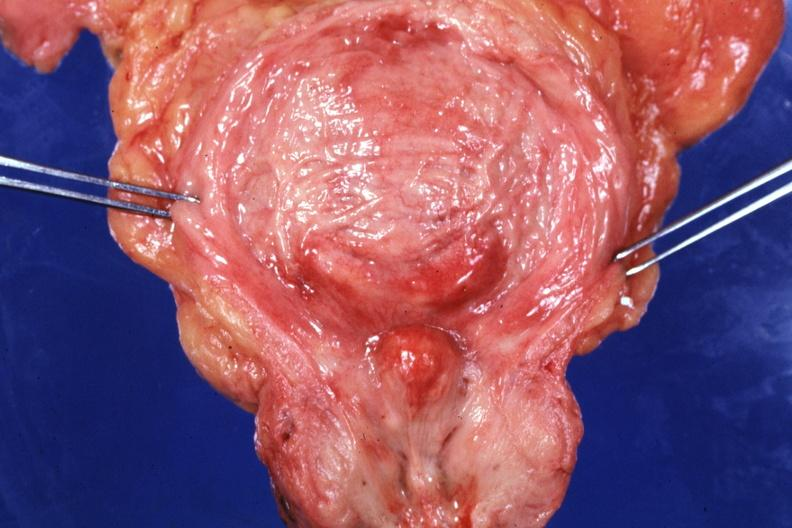what is present?
Answer the question using a single word or phrase. Prostate 